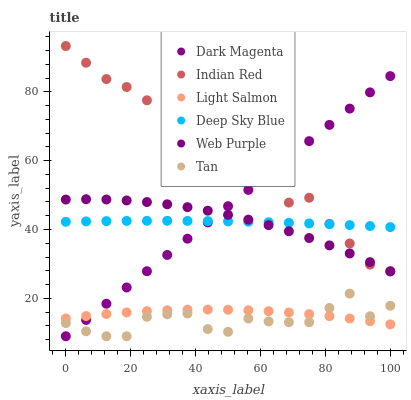Does Tan have the minimum area under the curve?
Answer yes or no. Yes. Does Indian Red have the maximum area under the curve?
Answer yes or no. Yes. Does Dark Magenta have the minimum area under the curve?
Answer yes or no. No. Does Dark Magenta have the maximum area under the curve?
Answer yes or no. No. Is Dark Magenta the smoothest?
Answer yes or no. Yes. Is Indian Red the roughest?
Answer yes or no. Yes. Is Web Purple the smoothest?
Answer yes or no. No. Is Web Purple the roughest?
Answer yes or no. No. Does Dark Magenta have the lowest value?
Answer yes or no. Yes. Does Web Purple have the lowest value?
Answer yes or no. No. Does Indian Red have the highest value?
Answer yes or no. Yes. Does Dark Magenta have the highest value?
Answer yes or no. No. Is Light Salmon less than Web Purple?
Answer yes or no. Yes. Is Web Purple greater than Light Salmon?
Answer yes or no. Yes. Does Dark Magenta intersect Web Purple?
Answer yes or no. Yes. Is Dark Magenta less than Web Purple?
Answer yes or no. No. Is Dark Magenta greater than Web Purple?
Answer yes or no. No. Does Light Salmon intersect Web Purple?
Answer yes or no. No. 